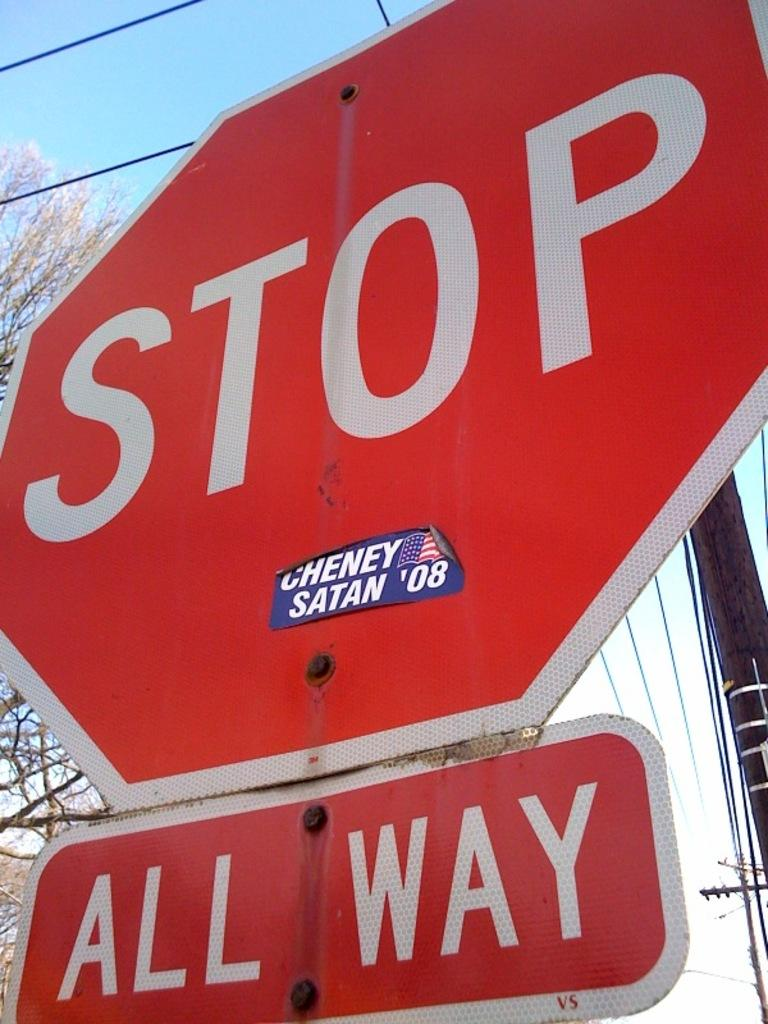<image>
Write a terse but informative summary of the picture. the word stop that is sitting outside in the day 